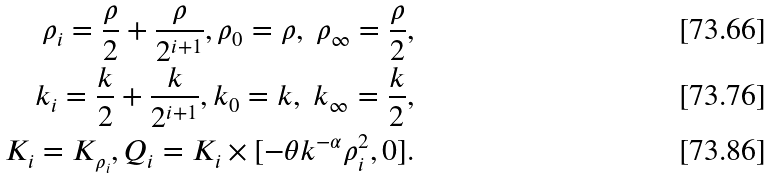<formula> <loc_0><loc_0><loc_500><loc_500>\rho _ { i } = \frac { \rho } { 2 } + \frac { \rho } { 2 ^ { i + 1 } } , \rho _ { 0 } = \rho , \ \rho _ { \infty } = \frac { \rho } { 2 } , \\ k _ { i } = \frac { k } { 2 } + \frac { k } { 2 ^ { i + 1 } } , k _ { 0 } = k , \ k _ { \infty } = \frac { k } { 2 } , \\ K _ { i } = K _ { \rho _ { i } } , Q _ { i } = K _ { i } \times [ - \theta k ^ { - \alpha } \rho _ { i } ^ { 2 } , 0 ] .</formula> 